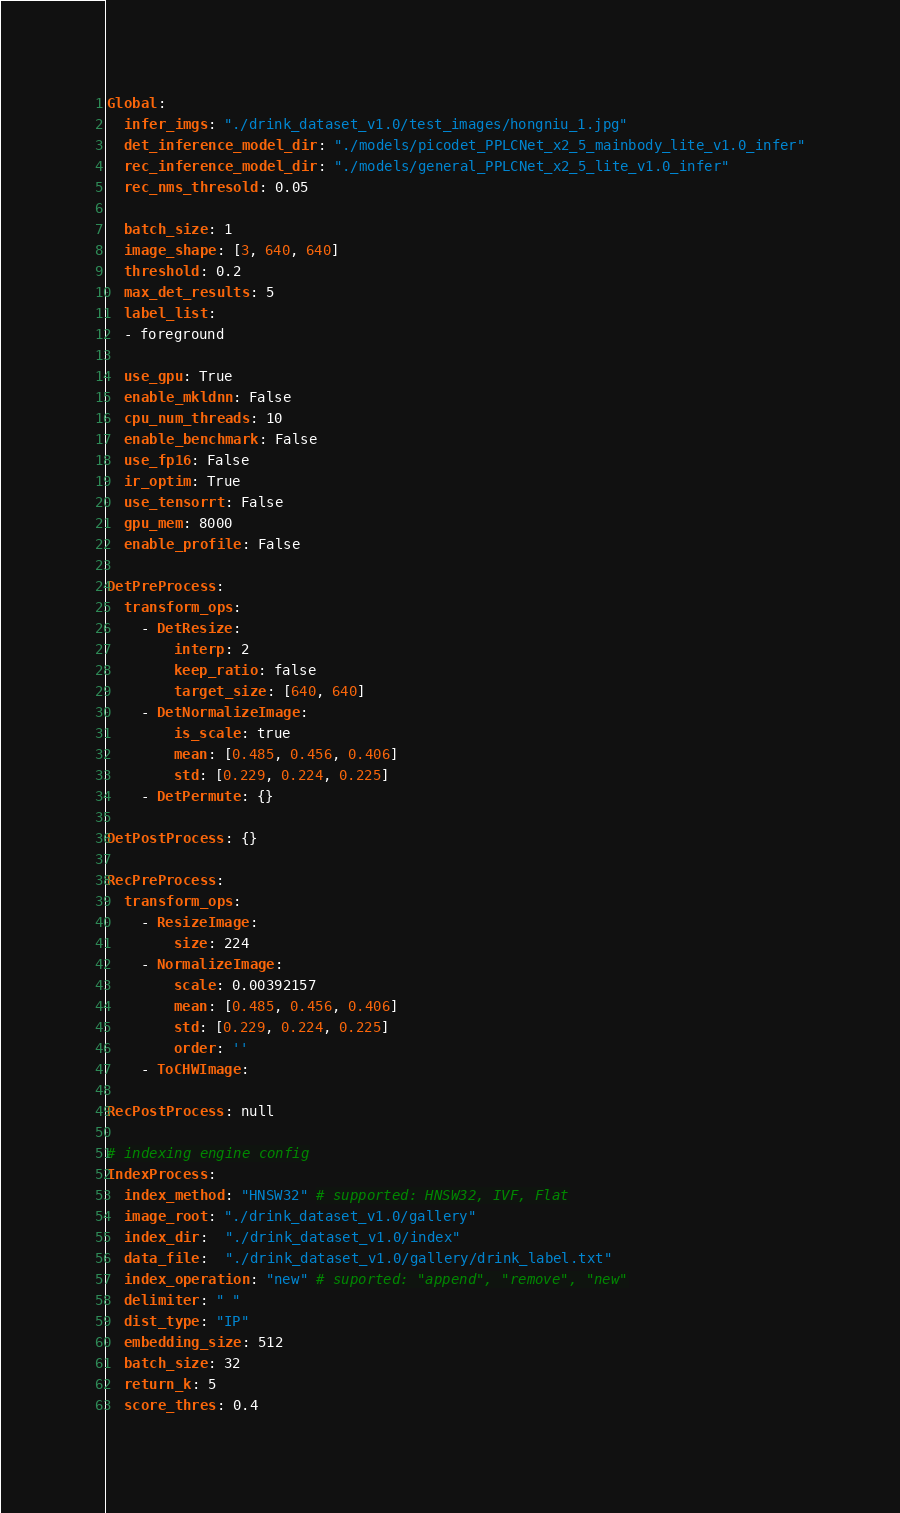Convert code to text. <code><loc_0><loc_0><loc_500><loc_500><_YAML_>Global:
  infer_imgs: "./drink_dataset_v1.0/test_images/hongniu_1.jpg"
  det_inference_model_dir: "./models/picodet_PPLCNet_x2_5_mainbody_lite_v1.0_infer"
  rec_inference_model_dir: "./models/general_PPLCNet_x2_5_lite_v1.0_infer"
  rec_nms_thresold: 0.05

  batch_size: 1
  image_shape: [3, 640, 640]
  threshold: 0.2
  max_det_results: 5
  label_list:
  - foreground

  use_gpu: True
  enable_mkldnn: False
  cpu_num_threads: 10
  enable_benchmark: False
  use_fp16: False
  ir_optim: True
  use_tensorrt: False
  gpu_mem: 8000
  enable_profile: False

DetPreProcess:
  transform_ops:
    - DetResize:
        interp: 2
        keep_ratio: false
        target_size: [640, 640]
    - DetNormalizeImage:
        is_scale: true
        mean: [0.485, 0.456, 0.406]
        std: [0.229, 0.224, 0.225]
    - DetPermute: {}

DetPostProcess: {}

RecPreProcess:
  transform_ops:
    - ResizeImage:
        size: 224
    - NormalizeImage:
        scale: 0.00392157
        mean: [0.485, 0.456, 0.406]
        std: [0.229, 0.224, 0.225]
        order: ''
    - ToCHWImage:

RecPostProcess: null

# indexing engine config
IndexProcess:
  index_method: "HNSW32" # supported: HNSW32, IVF, Flat
  image_root: "./drink_dataset_v1.0/gallery"
  index_dir:  "./drink_dataset_v1.0/index"
  data_file:  "./drink_dataset_v1.0/gallery/drink_label.txt"
  index_operation: "new" # suported: "append", "remove", "new"
  delimiter: " "
  dist_type: "IP"
  embedding_size: 512
  batch_size: 32
  return_k: 5
  score_thres: 0.4</code> 